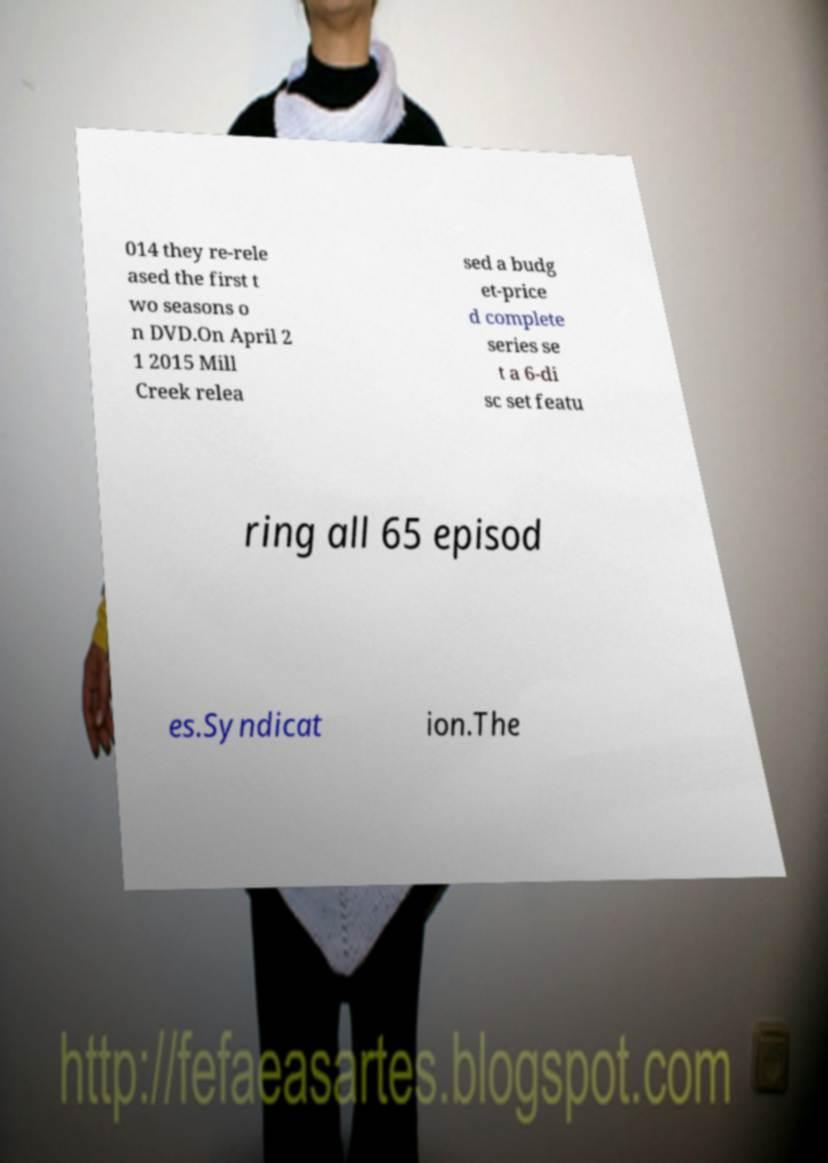Please identify and transcribe the text found in this image. 014 they re-rele ased the first t wo seasons o n DVD.On April 2 1 2015 Mill Creek relea sed a budg et-price d complete series se t a 6-di sc set featu ring all 65 episod es.Syndicat ion.The 